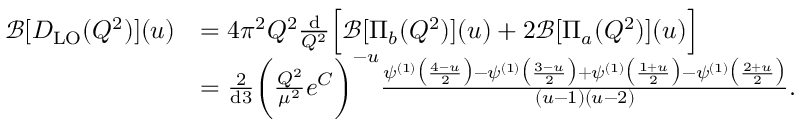Convert formula to latex. <formula><loc_0><loc_0><loc_500><loc_500>\begin{array} { r l } { \mathcal { B } [ D _ { L O } ( Q ^ { 2 } ) ] ( u ) } & { = 4 \pi ^ { 2 } Q ^ { 2 } \frac { d } { Q ^ { 2 } } \left [ \mathcal { B } [ \Pi _ { b } ( Q ^ { 2 } ) ] ( u ) + 2 \mathcal { B } [ \Pi _ { a } ( Q ^ { 2 } ) ] ( u ) \right ] } \\ & { = \frac { 2 } { d 3 } \left ( \frac { Q ^ { 2 } } { \mu ^ { 2 } } e ^ { C } \right ) ^ { - u } \frac { \psi ^ { ( 1 ) } \left ( \frac { 4 - u } { 2 } \right ) - \psi ^ { ( 1 ) } \left ( \frac { 3 - u } { 2 } \right ) + \psi ^ { ( 1 ) } \left ( \frac { 1 + u } { 2 } \right ) - \psi ^ { ( 1 ) } \left ( \frac { 2 + u } { 2 } \right ) } { ( u - 1 ) ( u - 2 ) } . } \end{array}</formula> 